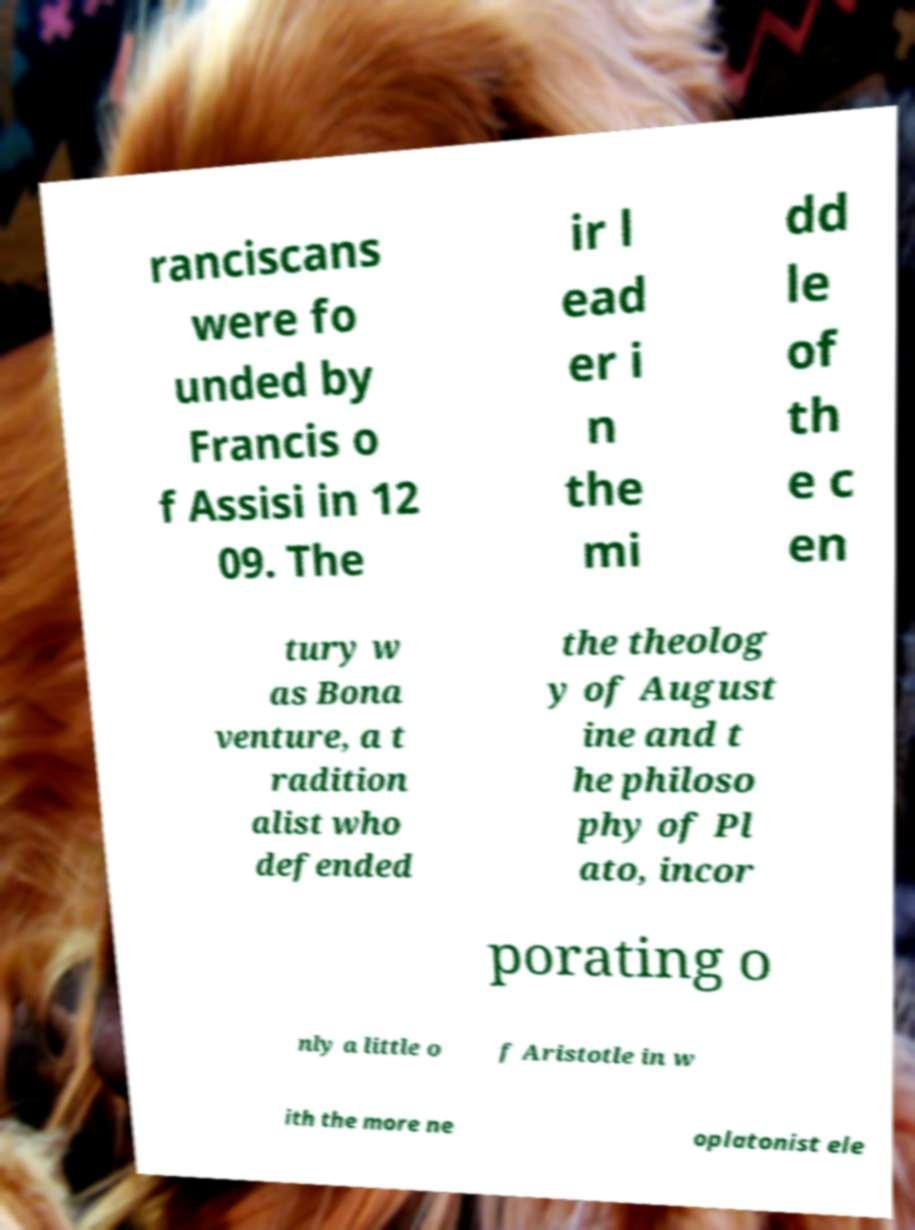Could you assist in decoding the text presented in this image and type it out clearly? ranciscans were fo unded by Francis o f Assisi in 12 09. The ir l ead er i n the mi dd le of th e c en tury w as Bona venture, a t radition alist who defended the theolog y of August ine and t he philoso phy of Pl ato, incor porating o nly a little o f Aristotle in w ith the more ne oplatonist ele 